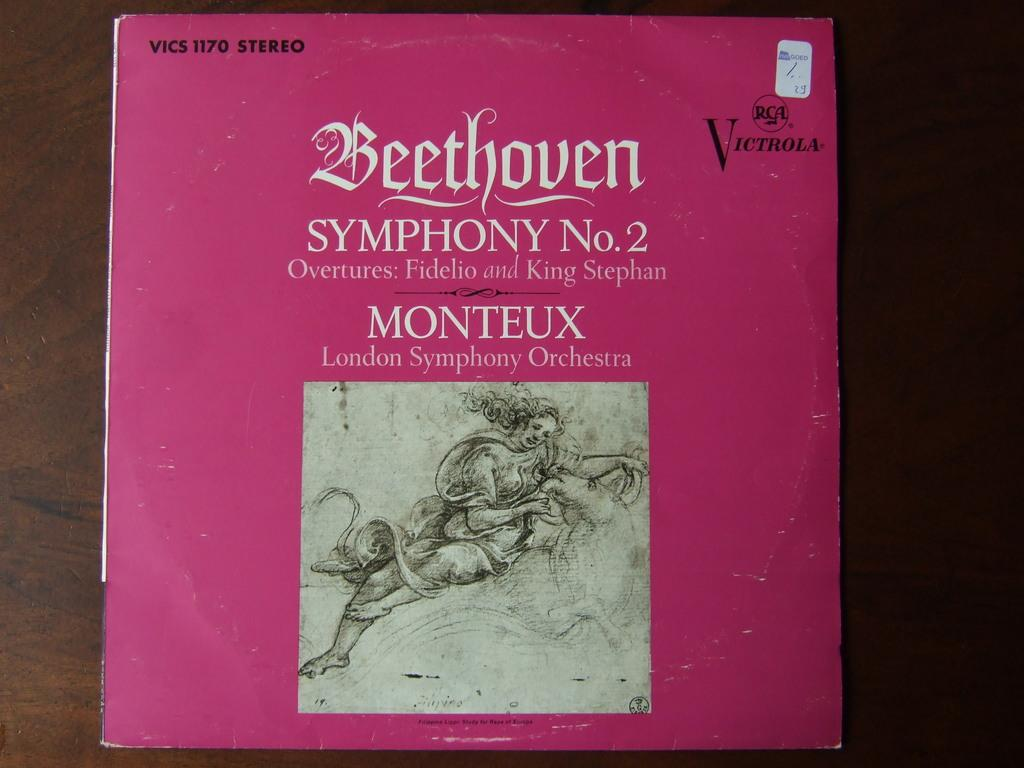<image>
Render a clear and concise summary of the photo. A pink covered music CD of Beethoven No. 2. 